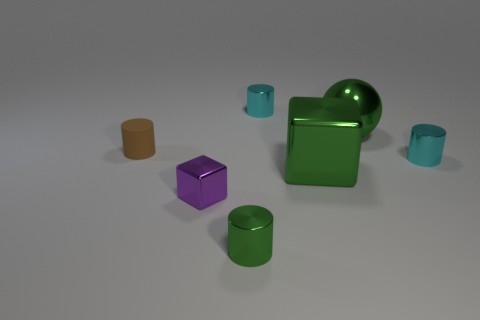Subtract all purple cubes. How many cubes are left? 1 Subtract all brown matte cylinders. How many cylinders are left? 3 Subtract all brown balls. Subtract all gray cylinders. How many balls are left? 1 Subtract all purple cubes. How many cyan cylinders are left? 2 Subtract all big blue matte cylinders. Subtract all cyan things. How many objects are left? 5 Add 4 purple things. How many purple things are left? 5 Add 6 metallic cylinders. How many metallic cylinders exist? 9 Add 3 tiny things. How many objects exist? 10 Subtract 1 green balls. How many objects are left? 6 Subtract all cylinders. How many objects are left? 3 